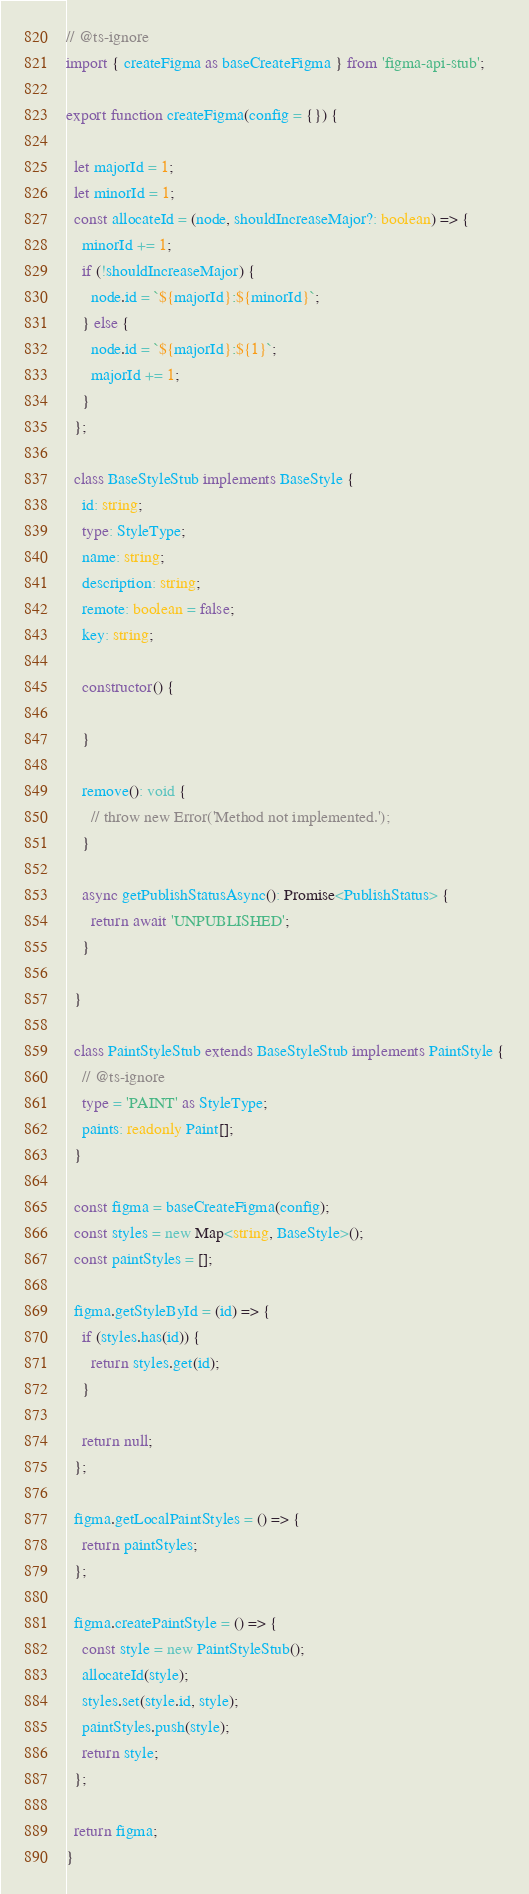<code> <loc_0><loc_0><loc_500><loc_500><_TypeScript_>// @ts-ignore
import { createFigma as baseCreateFigma } from 'figma-api-stub';

export function createFigma(config = {}) {

  let majorId = 1;
  let minorId = 1;
  const allocateId = (node, shouldIncreaseMajor?: boolean) => {
    minorId += 1;
    if (!shouldIncreaseMajor) {
      node.id = `${majorId}:${minorId}`;
    } else {
      node.id = `${majorId}:${1}`;
      majorId += 1;
    }
  };

  class BaseStyleStub implements BaseStyle {
    id: string;
    type: StyleType;
    name: string;
    description: string;
    remote: boolean = false;
    key: string;

    constructor() {
      
    }

    remove(): void {
      // throw new Error('Method not implemented.');
    }

    async getPublishStatusAsync(): Promise<PublishStatus> {
      return await 'UNPUBLISHED';
    }

  }

  class PaintStyleStub extends BaseStyleStub implements PaintStyle {
    // @ts-ignore
    type = 'PAINT' as StyleType;
    paints: readonly Paint[];
  }

  const figma = baseCreateFigma(config);
  const styles = new Map<string, BaseStyle>();
  const paintStyles = [];

  figma.getStyleById = (id) => {
    if (styles.has(id)) {
      return styles.get(id);
    }

    return null;
  };

  figma.getLocalPaintStyles = () => {
    return paintStyles;
  };

  figma.createPaintStyle = () => {
    const style = new PaintStyleStub();
    allocateId(style);
    styles.set(style.id, style);
    paintStyles.push(style);
    return style;
  };

  return figma;
}</code> 